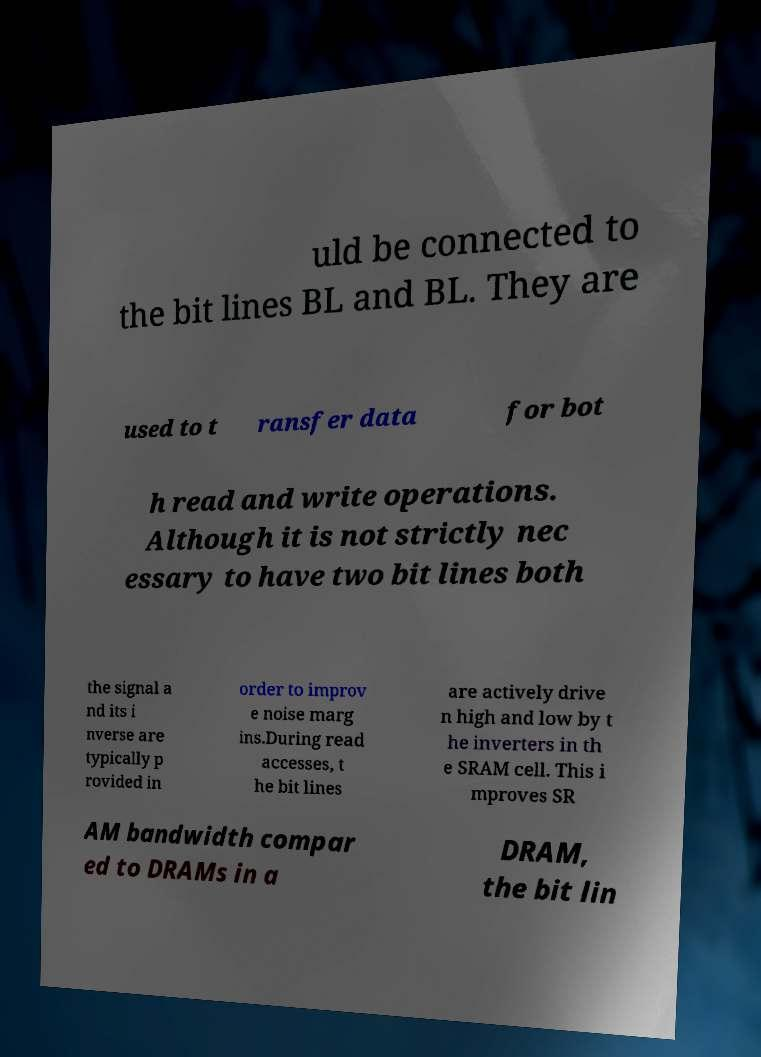For documentation purposes, I need the text within this image transcribed. Could you provide that? uld be connected to the bit lines BL and BL. They are used to t ransfer data for bot h read and write operations. Although it is not strictly nec essary to have two bit lines both the signal a nd its i nverse are typically p rovided in order to improv e noise marg ins.During read accesses, t he bit lines are actively drive n high and low by t he inverters in th e SRAM cell. This i mproves SR AM bandwidth compar ed to DRAMs in a DRAM, the bit lin 